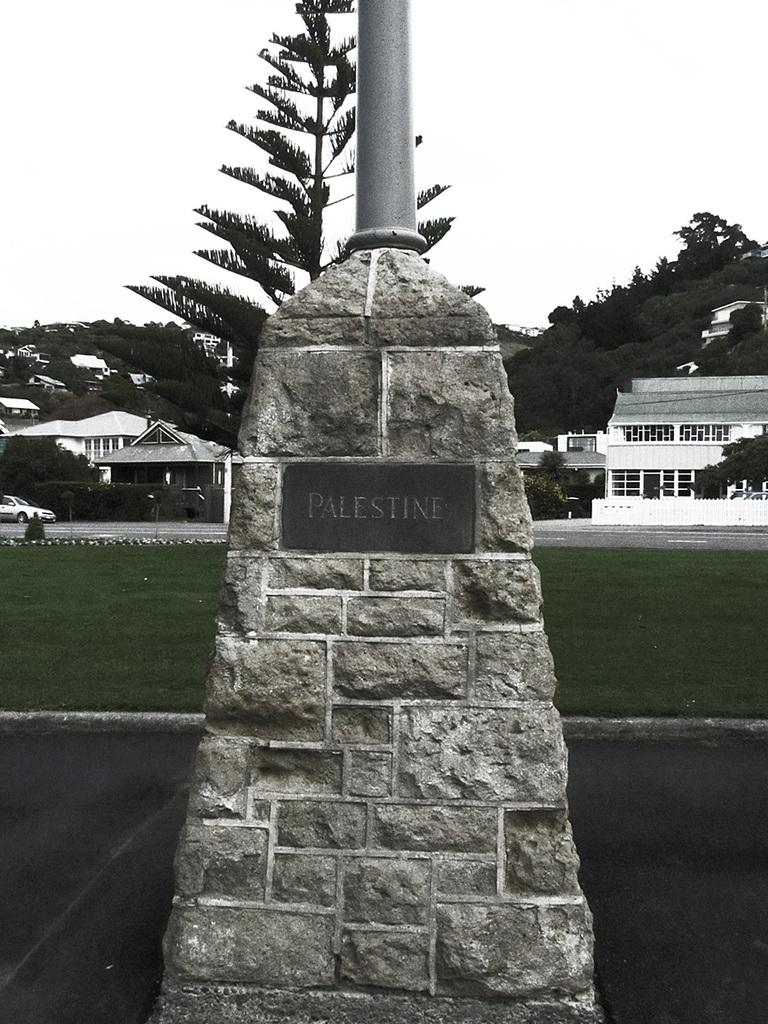What is the main structure in the image? There is a stone pillar in the image. What is attached to the stone pillar? The stone pillar has a name board on it. What is on top of the stone pillar? There is a pole on top of the stone pillar. What can be seen in the distance in the image? There are buildings and trees visible in the background of the image. Where is the monkey playing in the yard in the image? There is no monkey or yard present in the image. What type of wood is used to construct the stone pillar in the image? The stone pillar is made of stone, not wood. 